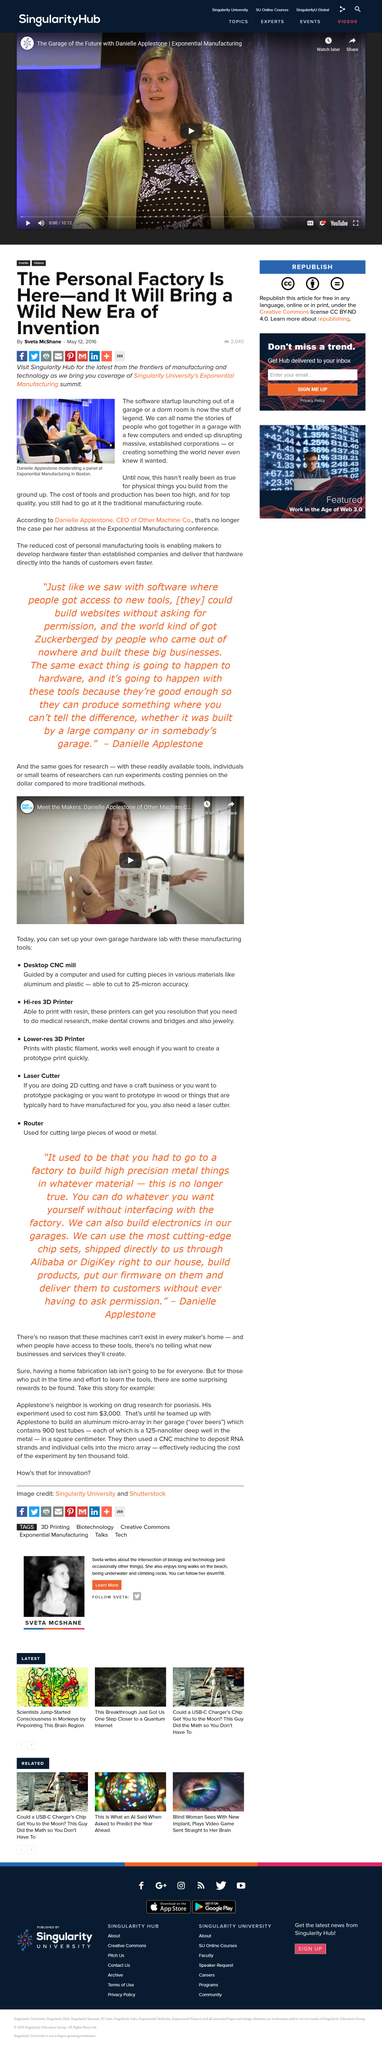Give some essential details in this illustration. The cost of tools and production has been excessive, as indicated by the affirmative response to the question. The software startup launching out of a garage or a dorm room is considered the stuff of legend. The speaker has stated that Danielle Applestone is moderating the panel in the image. 